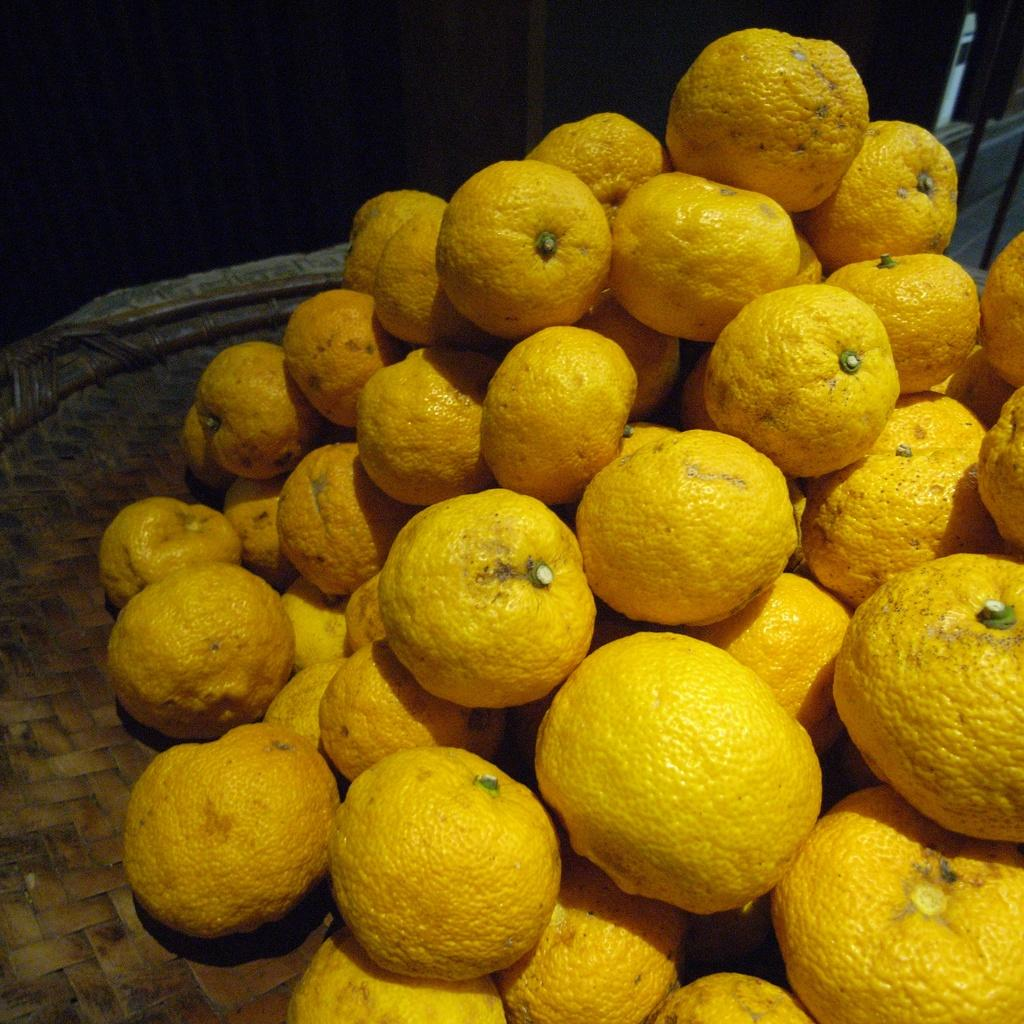What type of fruit is present in the image? There are many oranges in the image. Where are the oranges located in the image? The oranges are placed on a path. What type of behavior can be observed in the oranges in the image? There is no behavior to observe in the oranges, as they are inanimate objects. 